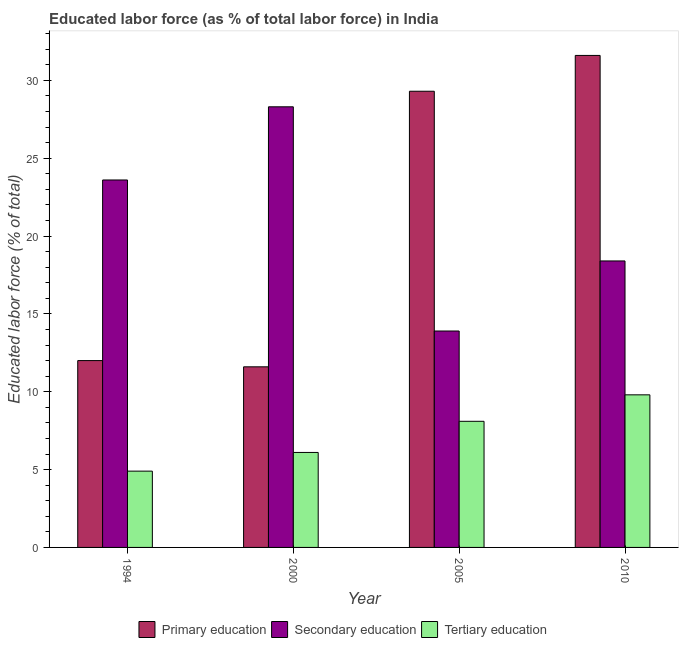How many groups of bars are there?
Your answer should be compact. 4. How many bars are there on the 2nd tick from the left?
Make the answer very short. 3. In how many cases, is the number of bars for a given year not equal to the number of legend labels?
Offer a very short reply. 0. What is the percentage of labor force who received tertiary education in 1994?
Offer a very short reply. 4.9. Across all years, what is the maximum percentage of labor force who received primary education?
Your response must be concise. 31.6. Across all years, what is the minimum percentage of labor force who received tertiary education?
Offer a terse response. 4.9. In which year was the percentage of labor force who received primary education maximum?
Provide a succinct answer. 2010. In which year was the percentage of labor force who received secondary education minimum?
Offer a very short reply. 2005. What is the total percentage of labor force who received tertiary education in the graph?
Your answer should be compact. 28.9. What is the difference between the percentage of labor force who received primary education in 2000 and that in 2005?
Your response must be concise. -17.7. What is the difference between the percentage of labor force who received tertiary education in 2000 and the percentage of labor force who received primary education in 2005?
Provide a succinct answer. -2. What is the average percentage of labor force who received secondary education per year?
Give a very brief answer. 21.05. In the year 2010, what is the difference between the percentage of labor force who received secondary education and percentage of labor force who received primary education?
Offer a very short reply. 0. In how many years, is the percentage of labor force who received tertiary education greater than 4 %?
Give a very brief answer. 4. What is the ratio of the percentage of labor force who received primary education in 2005 to that in 2010?
Your response must be concise. 0.93. Is the percentage of labor force who received primary education in 2005 less than that in 2010?
Your answer should be very brief. Yes. Is the difference between the percentage of labor force who received primary education in 2005 and 2010 greater than the difference between the percentage of labor force who received tertiary education in 2005 and 2010?
Give a very brief answer. No. What is the difference between the highest and the second highest percentage of labor force who received secondary education?
Your answer should be compact. 4.7. What is the difference between the highest and the lowest percentage of labor force who received tertiary education?
Offer a very short reply. 4.9. In how many years, is the percentage of labor force who received secondary education greater than the average percentage of labor force who received secondary education taken over all years?
Make the answer very short. 2. Is the sum of the percentage of labor force who received tertiary education in 2000 and 2005 greater than the maximum percentage of labor force who received secondary education across all years?
Your answer should be compact. Yes. What does the 1st bar from the right in 2000 represents?
Offer a very short reply. Tertiary education. Are all the bars in the graph horizontal?
Offer a very short reply. No. What is the difference between two consecutive major ticks on the Y-axis?
Your answer should be compact. 5. Are the values on the major ticks of Y-axis written in scientific E-notation?
Provide a short and direct response. No. Does the graph contain any zero values?
Your answer should be compact. No. Does the graph contain grids?
Your response must be concise. No. Where does the legend appear in the graph?
Provide a succinct answer. Bottom center. How are the legend labels stacked?
Provide a short and direct response. Horizontal. What is the title of the graph?
Give a very brief answer. Educated labor force (as % of total labor force) in India. What is the label or title of the Y-axis?
Offer a terse response. Educated labor force (% of total). What is the Educated labor force (% of total) of Primary education in 1994?
Provide a succinct answer. 12. What is the Educated labor force (% of total) in Secondary education in 1994?
Provide a succinct answer. 23.6. What is the Educated labor force (% of total) of Tertiary education in 1994?
Keep it short and to the point. 4.9. What is the Educated labor force (% of total) in Primary education in 2000?
Your answer should be very brief. 11.6. What is the Educated labor force (% of total) of Secondary education in 2000?
Your answer should be very brief. 28.3. What is the Educated labor force (% of total) of Tertiary education in 2000?
Your answer should be very brief. 6.1. What is the Educated labor force (% of total) in Primary education in 2005?
Offer a terse response. 29.3. What is the Educated labor force (% of total) in Secondary education in 2005?
Give a very brief answer. 13.9. What is the Educated labor force (% of total) of Tertiary education in 2005?
Keep it short and to the point. 8.1. What is the Educated labor force (% of total) of Primary education in 2010?
Provide a short and direct response. 31.6. What is the Educated labor force (% of total) of Secondary education in 2010?
Your answer should be very brief. 18.4. What is the Educated labor force (% of total) of Tertiary education in 2010?
Keep it short and to the point. 9.8. Across all years, what is the maximum Educated labor force (% of total) of Primary education?
Provide a short and direct response. 31.6. Across all years, what is the maximum Educated labor force (% of total) in Secondary education?
Your answer should be compact. 28.3. Across all years, what is the maximum Educated labor force (% of total) in Tertiary education?
Your response must be concise. 9.8. Across all years, what is the minimum Educated labor force (% of total) of Primary education?
Provide a succinct answer. 11.6. Across all years, what is the minimum Educated labor force (% of total) in Secondary education?
Give a very brief answer. 13.9. Across all years, what is the minimum Educated labor force (% of total) of Tertiary education?
Make the answer very short. 4.9. What is the total Educated labor force (% of total) in Primary education in the graph?
Offer a terse response. 84.5. What is the total Educated labor force (% of total) in Secondary education in the graph?
Offer a very short reply. 84.2. What is the total Educated labor force (% of total) in Tertiary education in the graph?
Ensure brevity in your answer.  28.9. What is the difference between the Educated labor force (% of total) of Primary education in 1994 and that in 2000?
Ensure brevity in your answer.  0.4. What is the difference between the Educated labor force (% of total) in Tertiary education in 1994 and that in 2000?
Your answer should be very brief. -1.2. What is the difference between the Educated labor force (% of total) in Primary education in 1994 and that in 2005?
Keep it short and to the point. -17.3. What is the difference between the Educated labor force (% of total) in Tertiary education in 1994 and that in 2005?
Provide a succinct answer. -3.2. What is the difference between the Educated labor force (% of total) of Primary education in 1994 and that in 2010?
Provide a short and direct response. -19.6. What is the difference between the Educated labor force (% of total) of Secondary education in 1994 and that in 2010?
Your answer should be compact. 5.2. What is the difference between the Educated labor force (% of total) in Tertiary education in 1994 and that in 2010?
Offer a terse response. -4.9. What is the difference between the Educated labor force (% of total) in Primary education in 2000 and that in 2005?
Offer a very short reply. -17.7. What is the difference between the Educated labor force (% of total) in Secondary education in 2000 and that in 2005?
Give a very brief answer. 14.4. What is the difference between the Educated labor force (% of total) in Primary education in 2000 and that in 2010?
Offer a terse response. -20. What is the difference between the Educated labor force (% of total) in Tertiary education in 2005 and that in 2010?
Your response must be concise. -1.7. What is the difference between the Educated labor force (% of total) of Primary education in 1994 and the Educated labor force (% of total) of Secondary education in 2000?
Give a very brief answer. -16.3. What is the difference between the Educated labor force (% of total) in Primary education in 1994 and the Educated labor force (% of total) in Tertiary education in 2000?
Your answer should be very brief. 5.9. What is the difference between the Educated labor force (% of total) in Secondary education in 1994 and the Educated labor force (% of total) in Tertiary education in 2000?
Your answer should be very brief. 17.5. What is the difference between the Educated labor force (% of total) in Primary education in 1994 and the Educated labor force (% of total) in Secondary education in 2005?
Provide a short and direct response. -1.9. What is the difference between the Educated labor force (% of total) of Secondary education in 1994 and the Educated labor force (% of total) of Tertiary education in 2010?
Provide a short and direct response. 13.8. What is the difference between the Educated labor force (% of total) of Primary education in 2000 and the Educated labor force (% of total) of Secondary education in 2005?
Your answer should be very brief. -2.3. What is the difference between the Educated labor force (% of total) in Secondary education in 2000 and the Educated labor force (% of total) in Tertiary education in 2005?
Ensure brevity in your answer.  20.2. What is the difference between the Educated labor force (% of total) of Primary education in 2000 and the Educated labor force (% of total) of Secondary education in 2010?
Offer a terse response. -6.8. What is the difference between the Educated labor force (% of total) in Primary education in 2000 and the Educated labor force (% of total) in Tertiary education in 2010?
Keep it short and to the point. 1.8. What is the difference between the Educated labor force (% of total) in Primary education in 2005 and the Educated labor force (% of total) in Tertiary education in 2010?
Provide a short and direct response. 19.5. What is the average Educated labor force (% of total) of Primary education per year?
Your response must be concise. 21.12. What is the average Educated labor force (% of total) in Secondary education per year?
Offer a very short reply. 21.05. What is the average Educated labor force (% of total) of Tertiary education per year?
Make the answer very short. 7.22. In the year 1994, what is the difference between the Educated labor force (% of total) of Primary education and Educated labor force (% of total) of Secondary education?
Keep it short and to the point. -11.6. In the year 1994, what is the difference between the Educated labor force (% of total) of Secondary education and Educated labor force (% of total) of Tertiary education?
Offer a very short reply. 18.7. In the year 2000, what is the difference between the Educated labor force (% of total) in Primary education and Educated labor force (% of total) in Secondary education?
Keep it short and to the point. -16.7. In the year 2000, what is the difference between the Educated labor force (% of total) of Primary education and Educated labor force (% of total) of Tertiary education?
Offer a very short reply. 5.5. In the year 2005, what is the difference between the Educated labor force (% of total) in Primary education and Educated labor force (% of total) in Tertiary education?
Make the answer very short. 21.2. In the year 2005, what is the difference between the Educated labor force (% of total) of Secondary education and Educated labor force (% of total) of Tertiary education?
Your answer should be very brief. 5.8. In the year 2010, what is the difference between the Educated labor force (% of total) of Primary education and Educated labor force (% of total) of Secondary education?
Offer a terse response. 13.2. In the year 2010, what is the difference between the Educated labor force (% of total) of Primary education and Educated labor force (% of total) of Tertiary education?
Keep it short and to the point. 21.8. In the year 2010, what is the difference between the Educated labor force (% of total) in Secondary education and Educated labor force (% of total) in Tertiary education?
Make the answer very short. 8.6. What is the ratio of the Educated labor force (% of total) of Primary education in 1994 to that in 2000?
Ensure brevity in your answer.  1.03. What is the ratio of the Educated labor force (% of total) of Secondary education in 1994 to that in 2000?
Your response must be concise. 0.83. What is the ratio of the Educated labor force (% of total) of Tertiary education in 1994 to that in 2000?
Provide a short and direct response. 0.8. What is the ratio of the Educated labor force (% of total) in Primary education in 1994 to that in 2005?
Provide a succinct answer. 0.41. What is the ratio of the Educated labor force (% of total) in Secondary education in 1994 to that in 2005?
Offer a very short reply. 1.7. What is the ratio of the Educated labor force (% of total) of Tertiary education in 1994 to that in 2005?
Your response must be concise. 0.6. What is the ratio of the Educated labor force (% of total) of Primary education in 1994 to that in 2010?
Give a very brief answer. 0.38. What is the ratio of the Educated labor force (% of total) of Secondary education in 1994 to that in 2010?
Your answer should be very brief. 1.28. What is the ratio of the Educated labor force (% of total) of Tertiary education in 1994 to that in 2010?
Provide a succinct answer. 0.5. What is the ratio of the Educated labor force (% of total) in Primary education in 2000 to that in 2005?
Make the answer very short. 0.4. What is the ratio of the Educated labor force (% of total) of Secondary education in 2000 to that in 2005?
Your answer should be very brief. 2.04. What is the ratio of the Educated labor force (% of total) in Tertiary education in 2000 to that in 2005?
Ensure brevity in your answer.  0.75. What is the ratio of the Educated labor force (% of total) in Primary education in 2000 to that in 2010?
Your response must be concise. 0.37. What is the ratio of the Educated labor force (% of total) of Secondary education in 2000 to that in 2010?
Keep it short and to the point. 1.54. What is the ratio of the Educated labor force (% of total) of Tertiary education in 2000 to that in 2010?
Provide a short and direct response. 0.62. What is the ratio of the Educated labor force (% of total) of Primary education in 2005 to that in 2010?
Provide a short and direct response. 0.93. What is the ratio of the Educated labor force (% of total) in Secondary education in 2005 to that in 2010?
Your answer should be compact. 0.76. What is the ratio of the Educated labor force (% of total) of Tertiary education in 2005 to that in 2010?
Offer a very short reply. 0.83. What is the difference between the highest and the second highest Educated labor force (% of total) of Primary education?
Make the answer very short. 2.3. What is the difference between the highest and the second highest Educated labor force (% of total) of Secondary education?
Offer a terse response. 4.7. What is the difference between the highest and the second highest Educated labor force (% of total) in Tertiary education?
Offer a terse response. 1.7. 